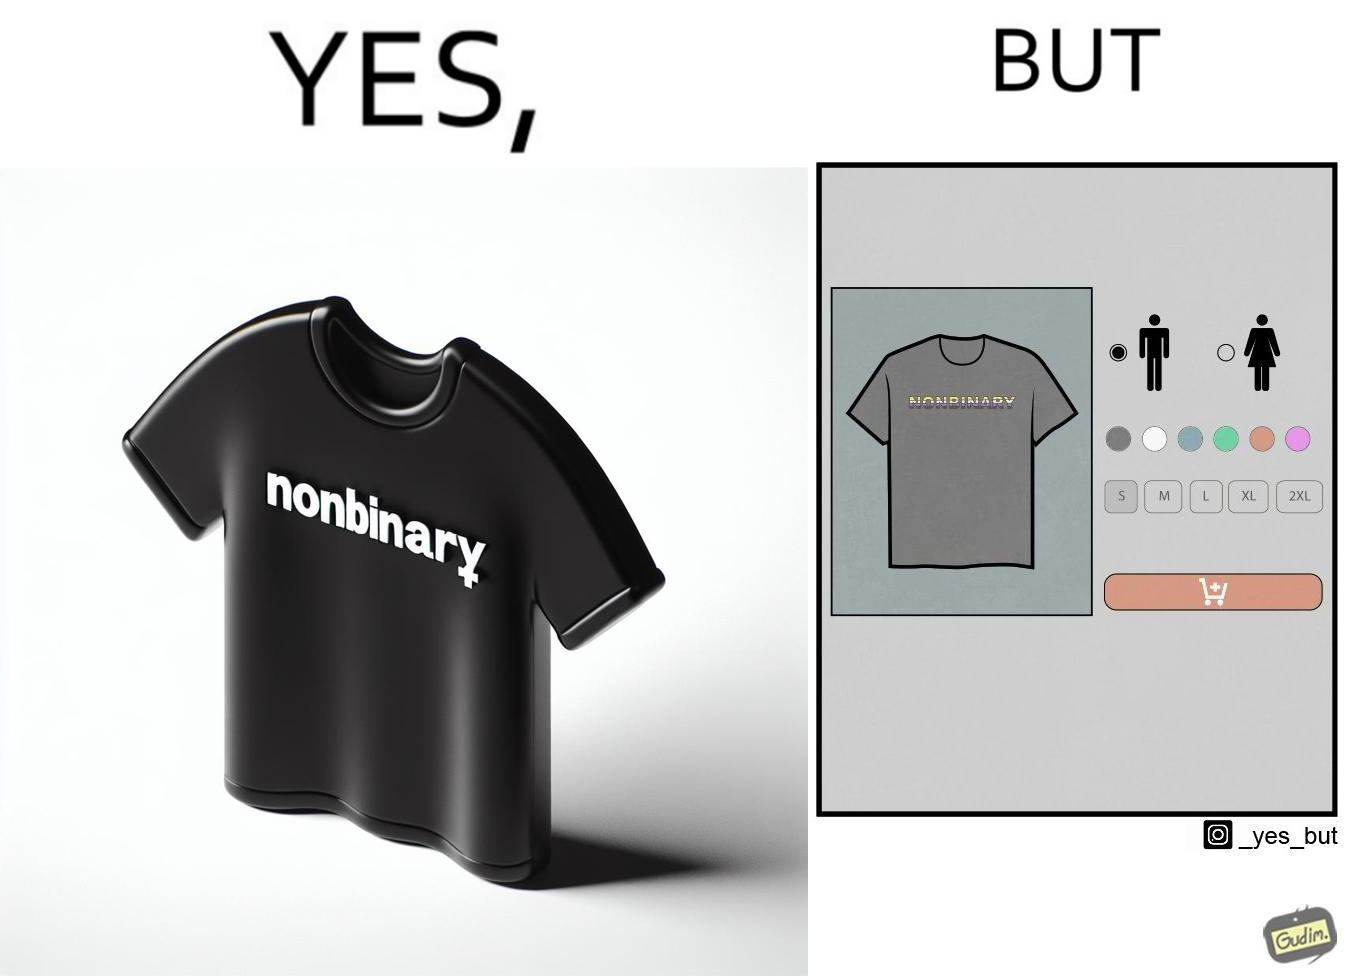Describe the satirical element in this image. The image is ironic, as the t-shirt that says "NONBINARY" has only 2 options for gender on an online retail forum. 